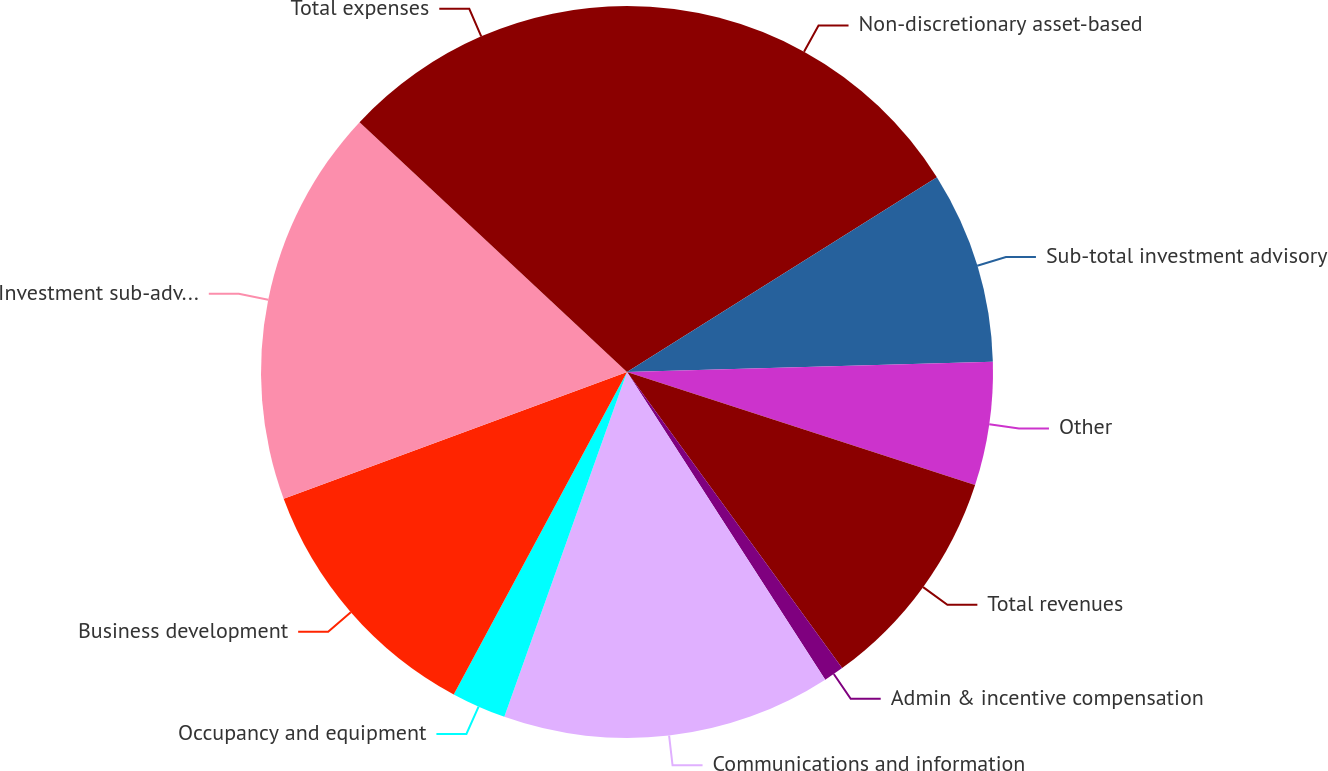<chart> <loc_0><loc_0><loc_500><loc_500><pie_chart><fcel>Non-discretionary asset-based<fcel>Sub-total investment advisory<fcel>Other<fcel>Total revenues<fcel>Admin & incentive compensation<fcel>Communications and information<fcel>Occupancy and equipment<fcel>Business development<fcel>Investment sub-advisory fees<fcel>Total expenses<nl><fcel>16.07%<fcel>8.48%<fcel>5.45%<fcel>10.0%<fcel>0.89%<fcel>14.55%<fcel>2.41%<fcel>11.52%<fcel>17.59%<fcel>13.04%<nl></chart> 